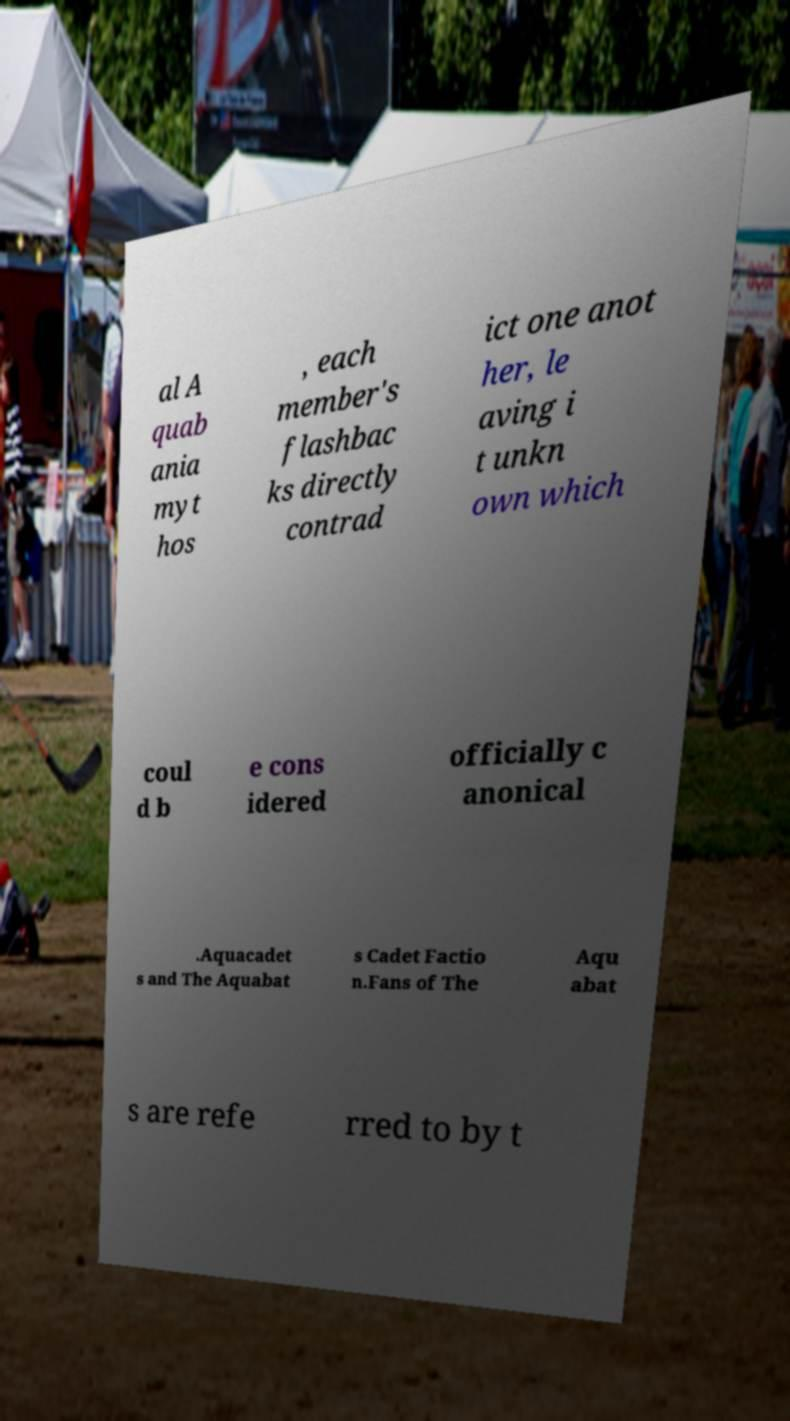Could you extract and type out the text from this image? al A quab ania myt hos , each member's flashbac ks directly contrad ict one anot her, le aving i t unkn own which coul d b e cons idered officially c anonical .Aquacadet s and The Aquabat s Cadet Factio n.Fans of The Aqu abat s are refe rred to by t 